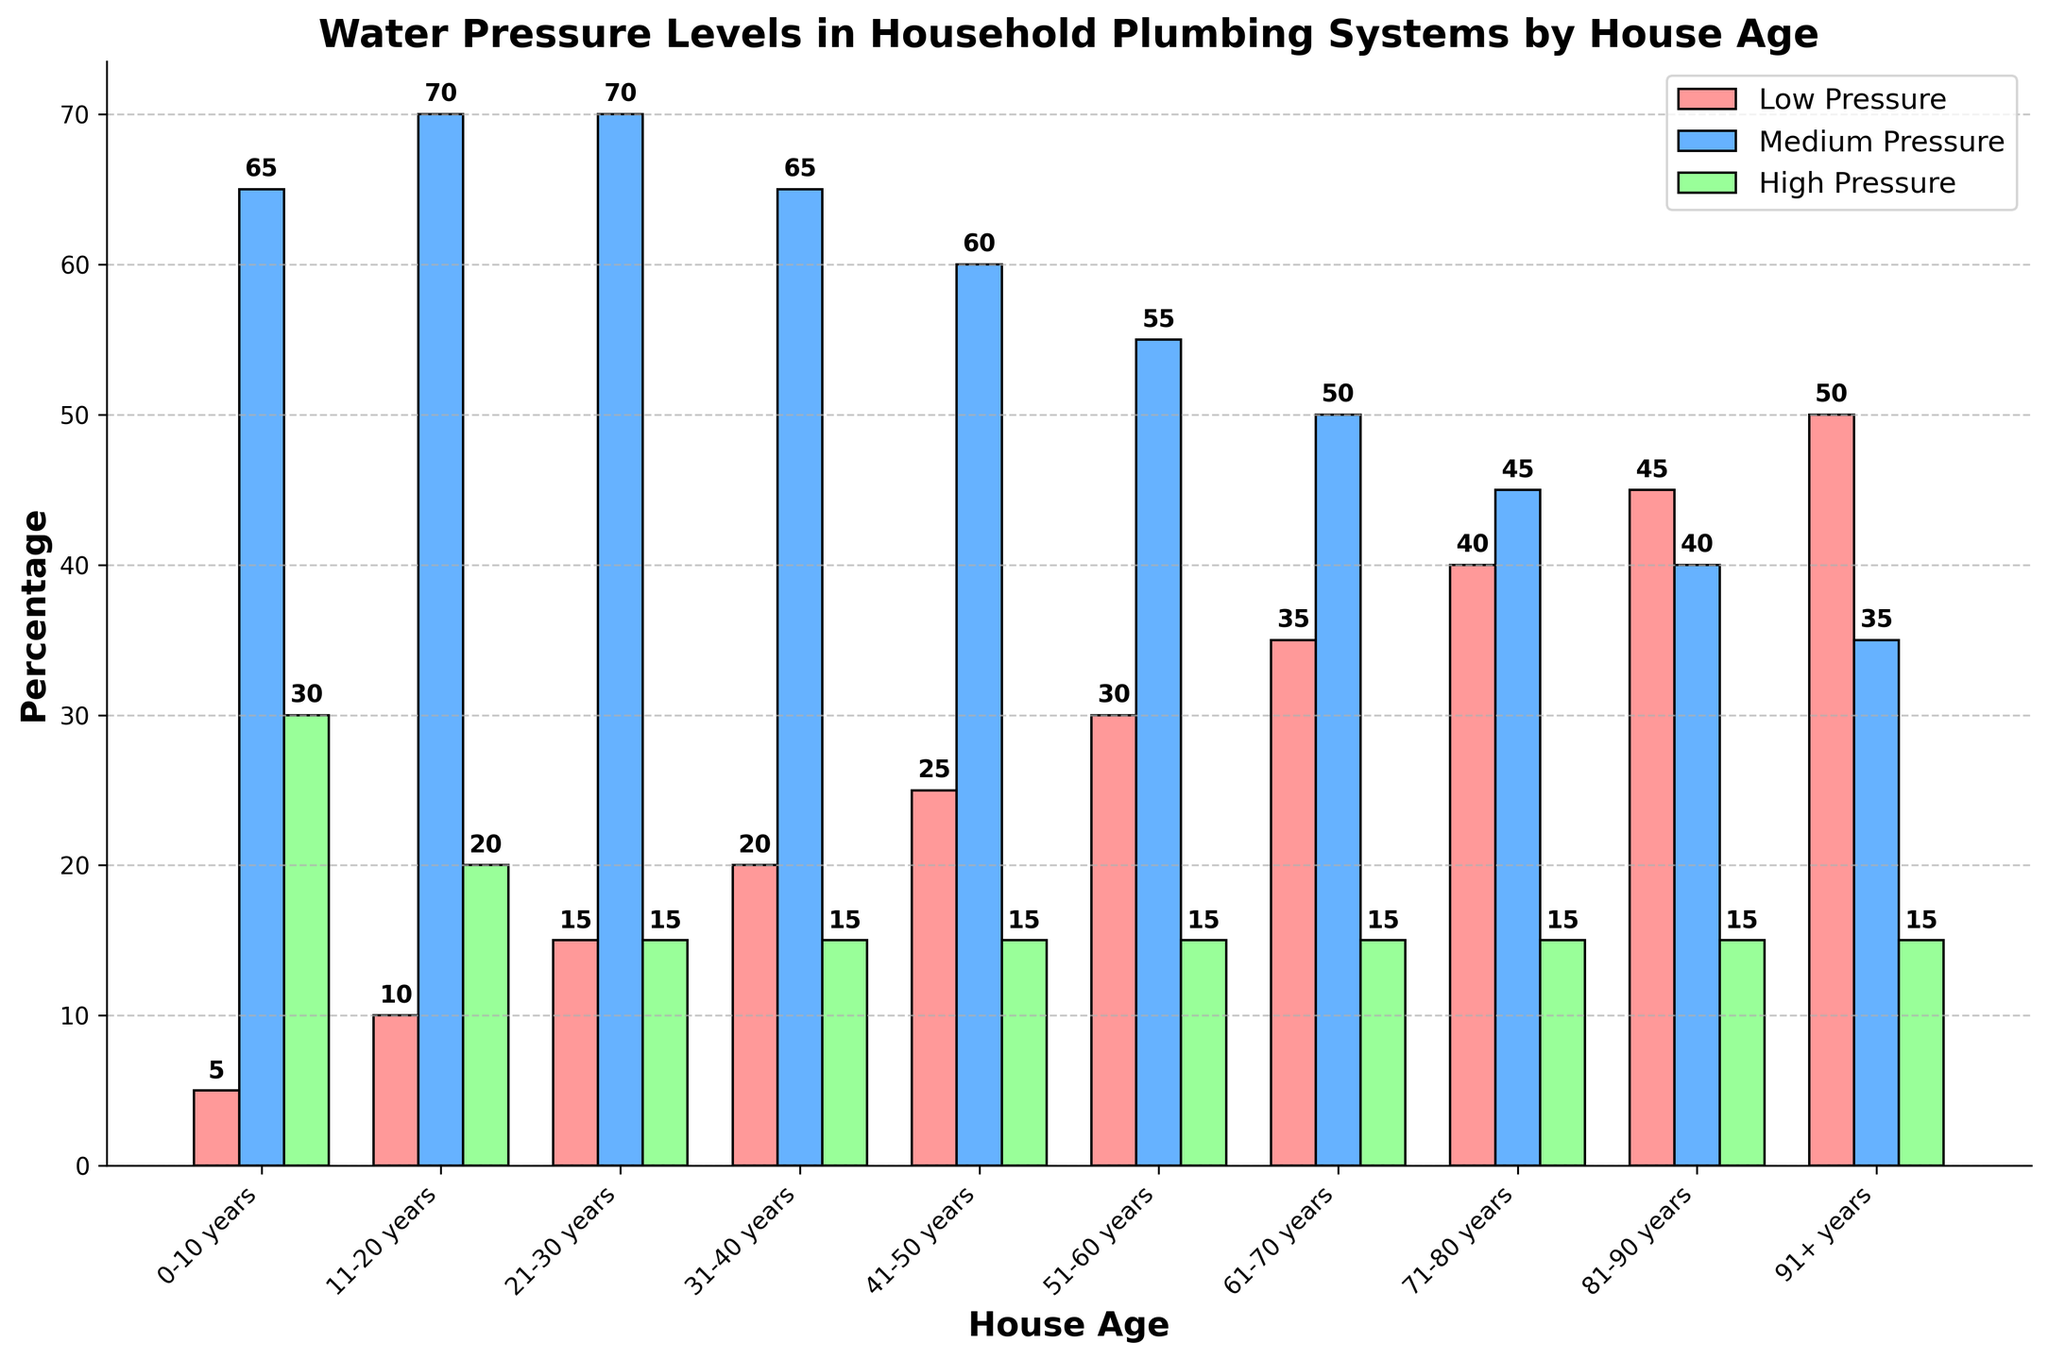What house age group has the highest percentage of low pressure? The bar representing low pressure (colored red) is tallest for the 91+ years house age group, indicating the highest percentage.
Answer: 91+ years Which house age group has the lowest percentage of medium pressure? The bar representing medium pressure (colored blue) is shortest for the 91+ years house age group, indicating the lowest percentage.
Answer: 91+ years What's the difference in low pressure percentages between the 11-20 years and 71-80 years age groups? To find the difference, subtract the percentage of low pressure for the 11-20 years age group (10%) from that of the 71-80 years age group (40%): 40% - 10% = 30%
Answer: 30% Which pressure level has the most consistent percentage across all house ages? The green bars representing high pressure (60+ PSI) show minimal variation and remain at 15% for almost every house age group.
Answer: High Pressure (60+ PSI) How does the percentage of medium pressure compare between the 0-10 years and 51-60 years age groups? The bar for medium pressure is taller for the 0-10 years age group (65%) compared to the 51-60 years age group (55%), indicating a higher percentage.
Answer: Higher for 0-10 years What is the combined percentage of low and medium pressures for the 21-30 years house age group? Add the low pressure (15%) and medium pressure (70%) percentages for the 21-30 years age group: 15% + 70% = 85%
Answer: 85% Which house age group has the largest percentage difference between low and high pressure levels? For the 91+ years age group, low pressure is at 50% and high pressure is at 15%. The difference is 50% - 15% = 35%, the largest among all age groups.
Answer: 91+ years What color represents the high pressure levels in the chart? The high pressure levels are represented by the green bars.
Answer: Green What is the trend in the percentage of low pressure as house age increases? The percentages of low pressure (red bars) gradually increase as the house age increases, showing a rising trend.
Answer: Increases What's the sum of percentages for all pressure levels in the 81-90 years house age group? Add the percentages of low pressure (45%), medium pressure (40%), and high pressure (15%): 45% + 40% + 15% = 100%
Answer: 100% 